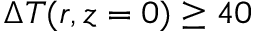Convert formula to latex. <formula><loc_0><loc_0><loc_500><loc_500>\Delta T ( r , z = 0 ) \geq 4 0</formula> 